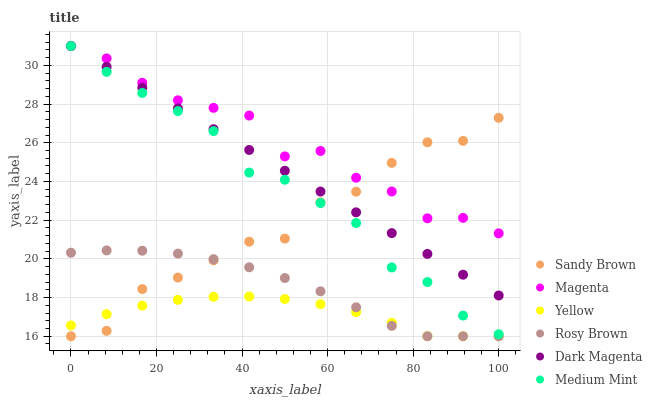Does Yellow have the minimum area under the curve?
Answer yes or no. Yes. Does Magenta have the maximum area under the curve?
Answer yes or no. Yes. Does Dark Magenta have the minimum area under the curve?
Answer yes or no. No. Does Dark Magenta have the maximum area under the curve?
Answer yes or no. No. Is Dark Magenta the smoothest?
Answer yes or no. Yes. Is Sandy Brown the roughest?
Answer yes or no. Yes. Is Rosy Brown the smoothest?
Answer yes or no. No. Is Rosy Brown the roughest?
Answer yes or no. No. Does Rosy Brown have the lowest value?
Answer yes or no. Yes. Does Dark Magenta have the lowest value?
Answer yes or no. No. Does Magenta have the highest value?
Answer yes or no. Yes. Does Rosy Brown have the highest value?
Answer yes or no. No. Is Yellow less than Magenta?
Answer yes or no. Yes. Is Dark Magenta greater than Rosy Brown?
Answer yes or no. Yes. Does Medium Mint intersect Sandy Brown?
Answer yes or no. Yes. Is Medium Mint less than Sandy Brown?
Answer yes or no. No. Is Medium Mint greater than Sandy Brown?
Answer yes or no. No. Does Yellow intersect Magenta?
Answer yes or no. No. 